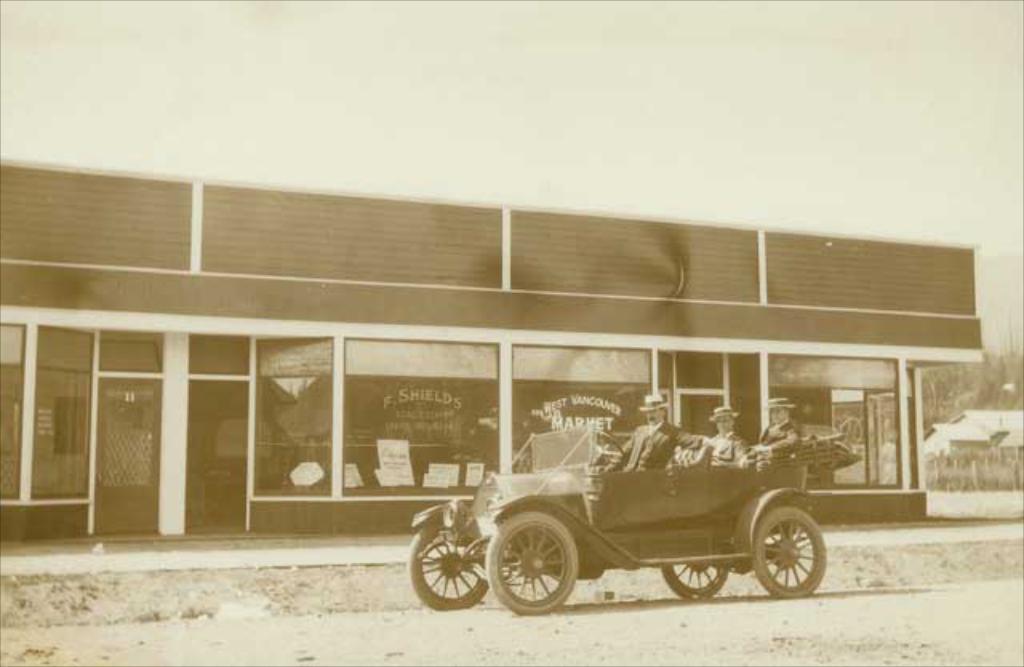How would you summarize this image in a sentence or two? In this image there are three persons sitting on the car, and at the background there are buildings, plants, trees,sky. 